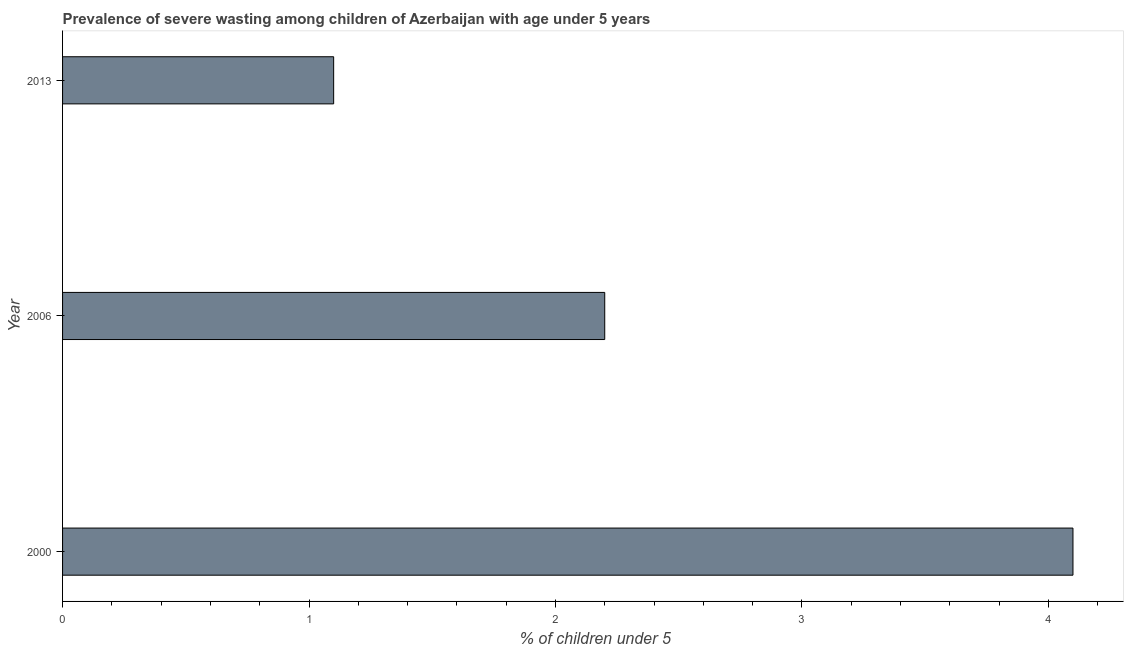Does the graph contain any zero values?
Offer a very short reply. No. Does the graph contain grids?
Make the answer very short. No. What is the title of the graph?
Make the answer very short. Prevalence of severe wasting among children of Azerbaijan with age under 5 years. What is the label or title of the X-axis?
Your answer should be compact.  % of children under 5. What is the prevalence of severe wasting in 2006?
Provide a succinct answer. 2.2. Across all years, what is the maximum prevalence of severe wasting?
Offer a terse response. 4.1. Across all years, what is the minimum prevalence of severe wasting?
Ensure brevity in your answer.  1.1. In which year was the prevalence of severe wasting minimum?
Ensure brevity in your answer.  2013. What is the sum of the prevalence of severe wasting?
Make the answer very short. 7.4. What is the difference between the prevalence of severe wasting in 2000 and 2013?
Keep it short and to the point. 3. What is the average prevalence of severe wasting per year?
Keep it short and to the point. 2.47. What is the median prevalence of severe wasting?
Your response must be concise. 2.2. In how many years, is the prevalence of severe wasting greater than 1 %?
Provide a succinct answer. 3. Do a majority of the years between 2006 and 2013 (inclusive) have prevalence of severe wasting greater than 3.4 %?
Provide a succinct answer. No. What is the ratio of the prevalence of severe wasting in 2000 to that in 2013?
Keep it short and to the point. 3.73. Is the prevalence of severe wasting in 2000 less than that in 2006?
Offer a very short reply. No. What is the difference between the highest and the second highest prevalence of severe wasting?
Offer a terse response. 1.9. Is the sum of the prevalence of severe wasting in 2006 and 2013 greater than the maximum prevalence of severe wasting across all years?
Your answer should be very brief. No. Are all the bars in the graph horizontal?
Offer a very short reply. Yes. How many years are there in the graph?
Make the answer very short. 3. What is the difference between two consecutive major ticks on the X-axis?
Provide a short and direct response. 1. What is the  % of children under 5 in 2000?
Keep it short and to the point. 4.1. What is the  % of children under 5 of 2006?
Offer a terse response. 2.2. What is the  % of children under 5 of 2013?
Offer a very short reply. 1.1. What is the difference between the  % of children under 5 in 2000 and 2006?
Offer a very short reply. 1.9. What is the difference between the  % of children under 5 in 2000 and 2013?
Your response must be concise. 3. What is the ratio of the  % of children under 5 in 2000 to that in 2006?
Your response must be concise. 1.86. What is the ratio of the  % of children under 5 in 2000 to that in 2013?
Provide a succinct answer. 3.73. What is the ratio of the  % of children under 5 in 2006 to that in 2013?
Your answer should be very brief. 2. 